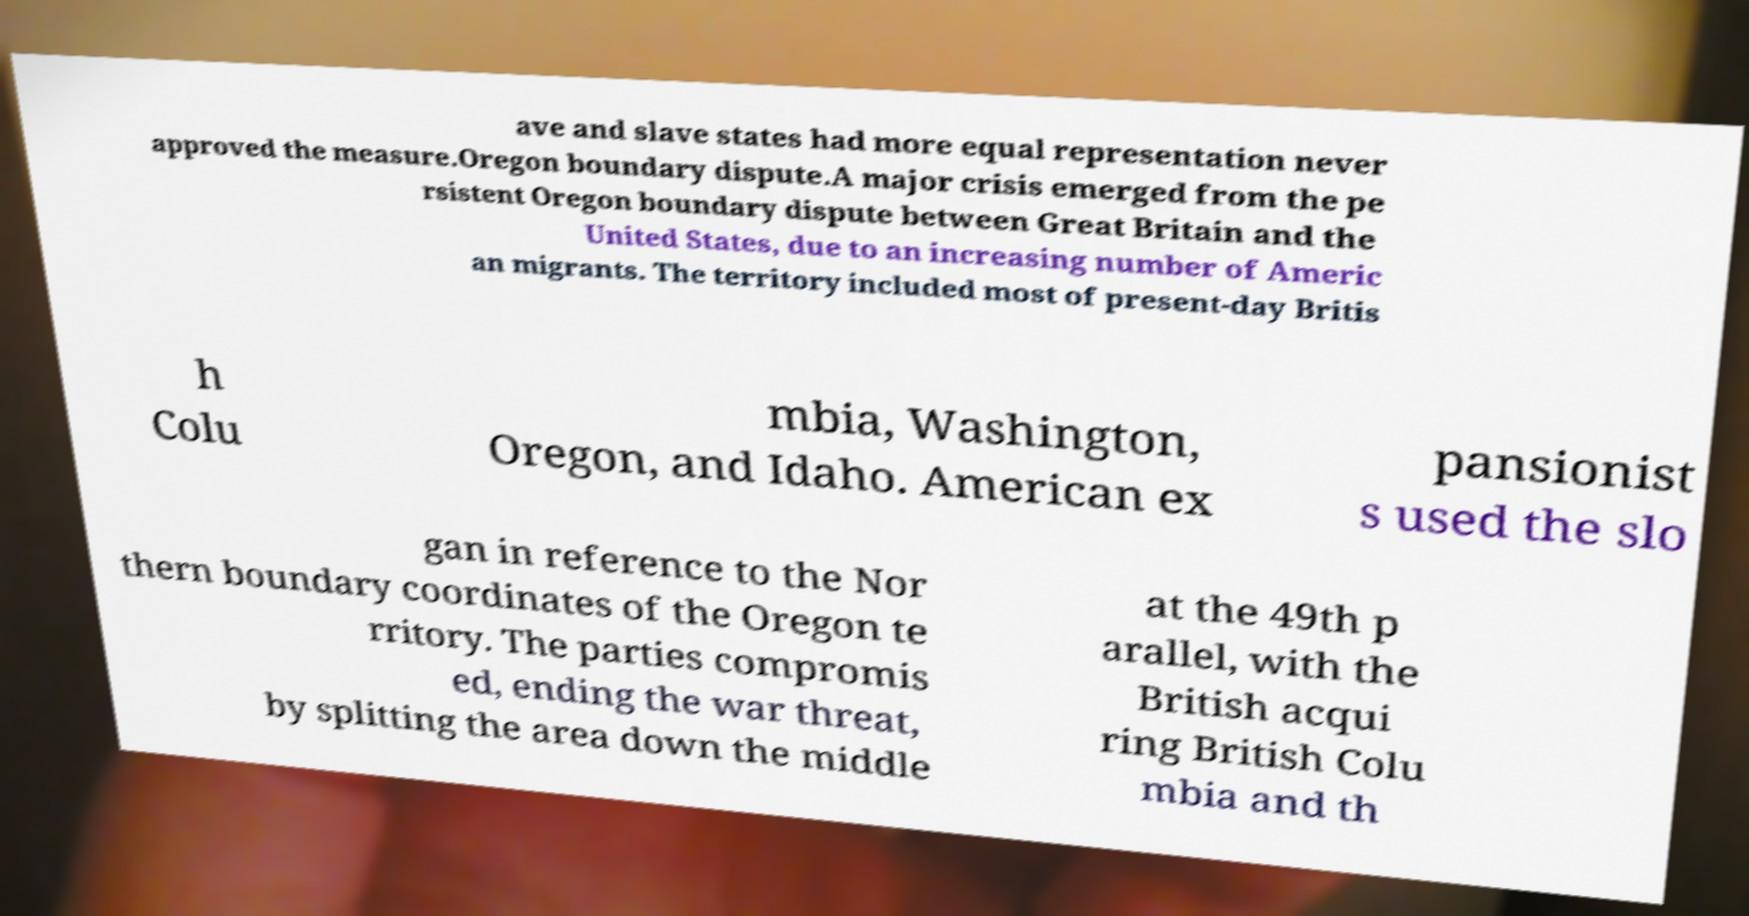Could you extract and type out the text from this image? ave and slave states had more equal representation never approved the measure.Oregon boundary dispute.A major crisis emerged from the pe rsistent Oregon boundary dispute between Great Britain and the United States, due to an increasing number of Americ an migrants. The territory included most of present-day Britis h Colu mbia, Washington, Oregon, and Idaho. American ex pansionist s used the slo gan in reference to the Nor thern boundary coordinates of the Oregon te rritory. The parties compromis ed, ending the war threat, by splitting the area down the middle at the 49th p arallel, with the British acqui ring British Colu mbia and th 